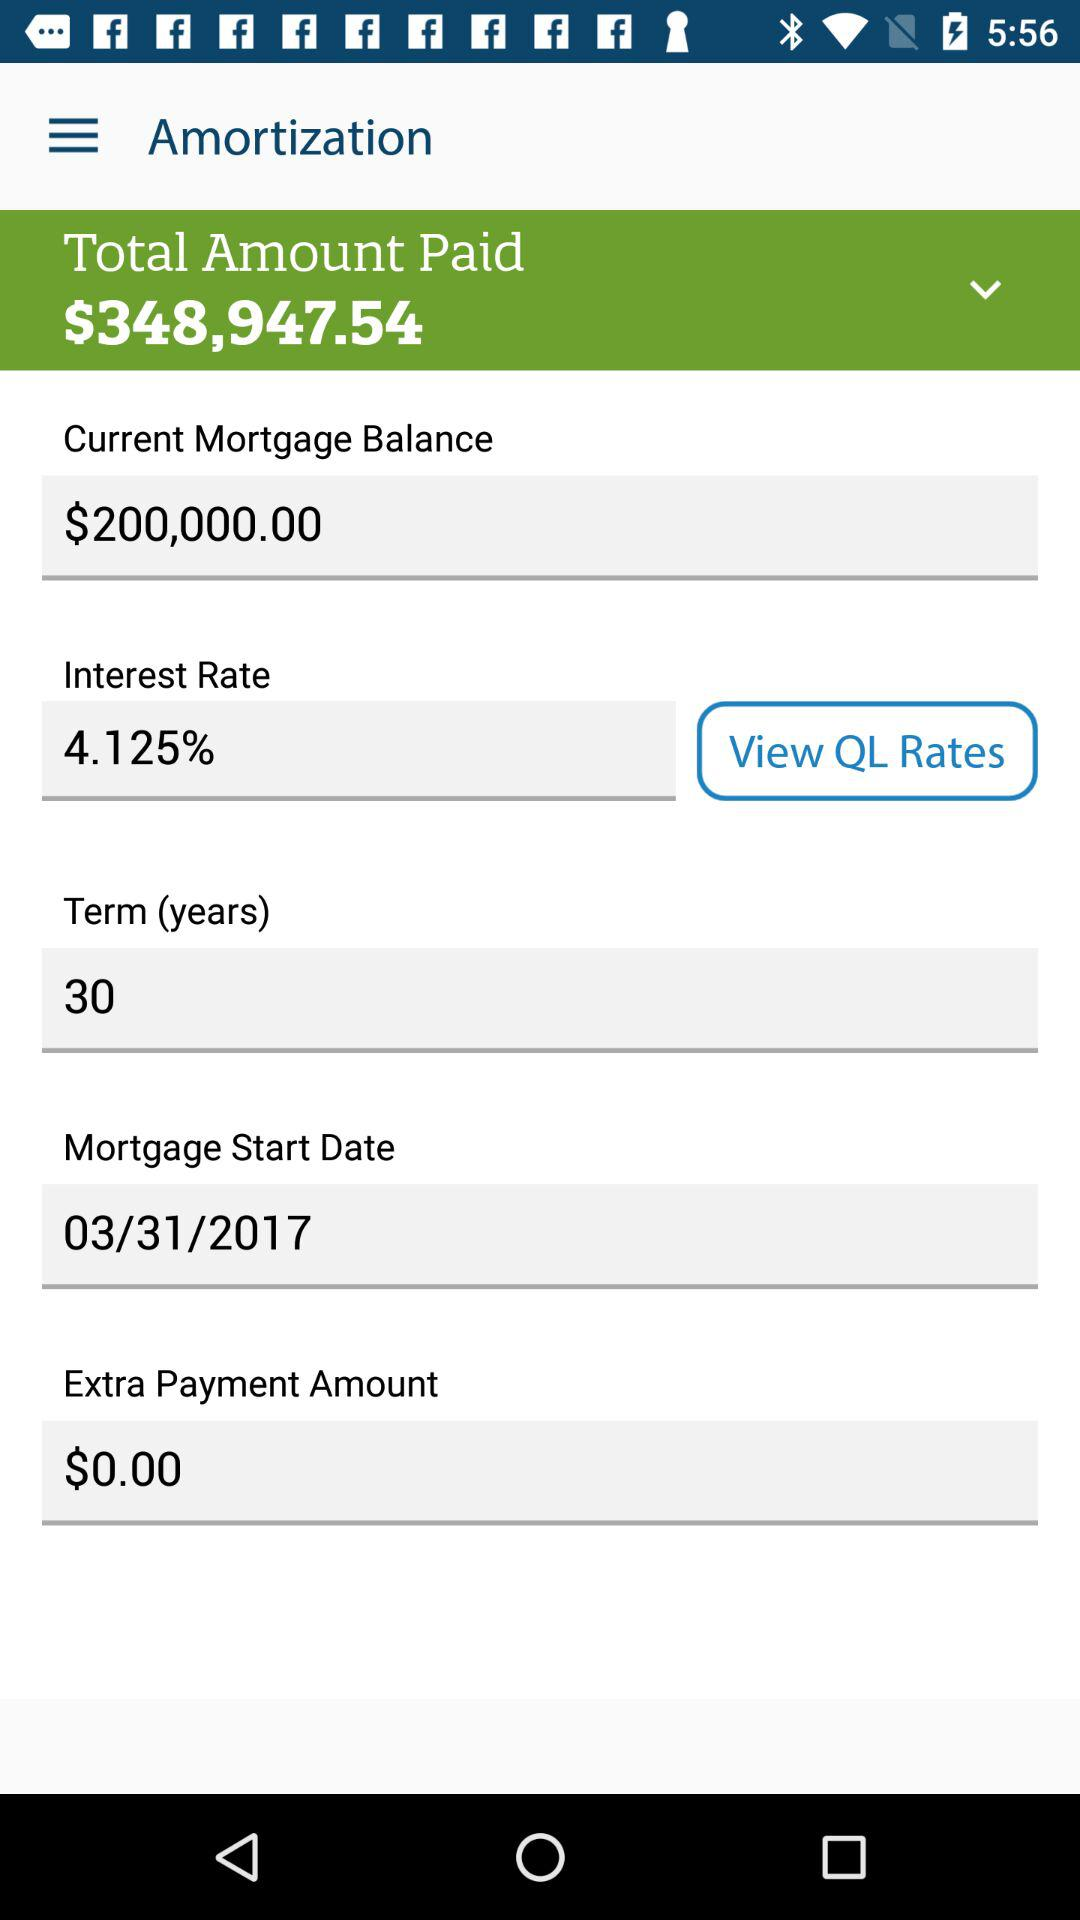What is the current mortgage balance? The current mortgage balance is $200,000.00. 